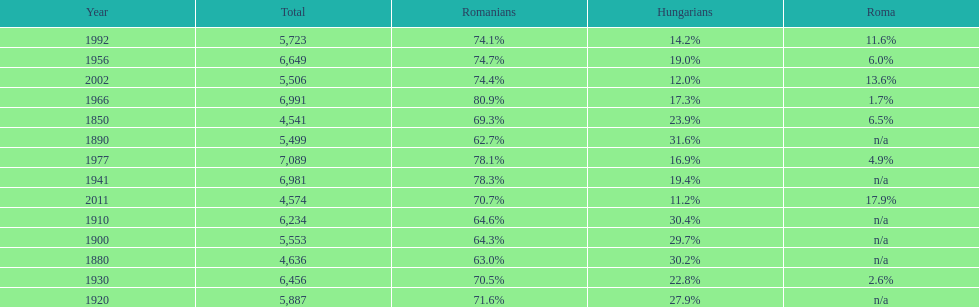What year had the next highest percentage for roma after 2011? 2002. 